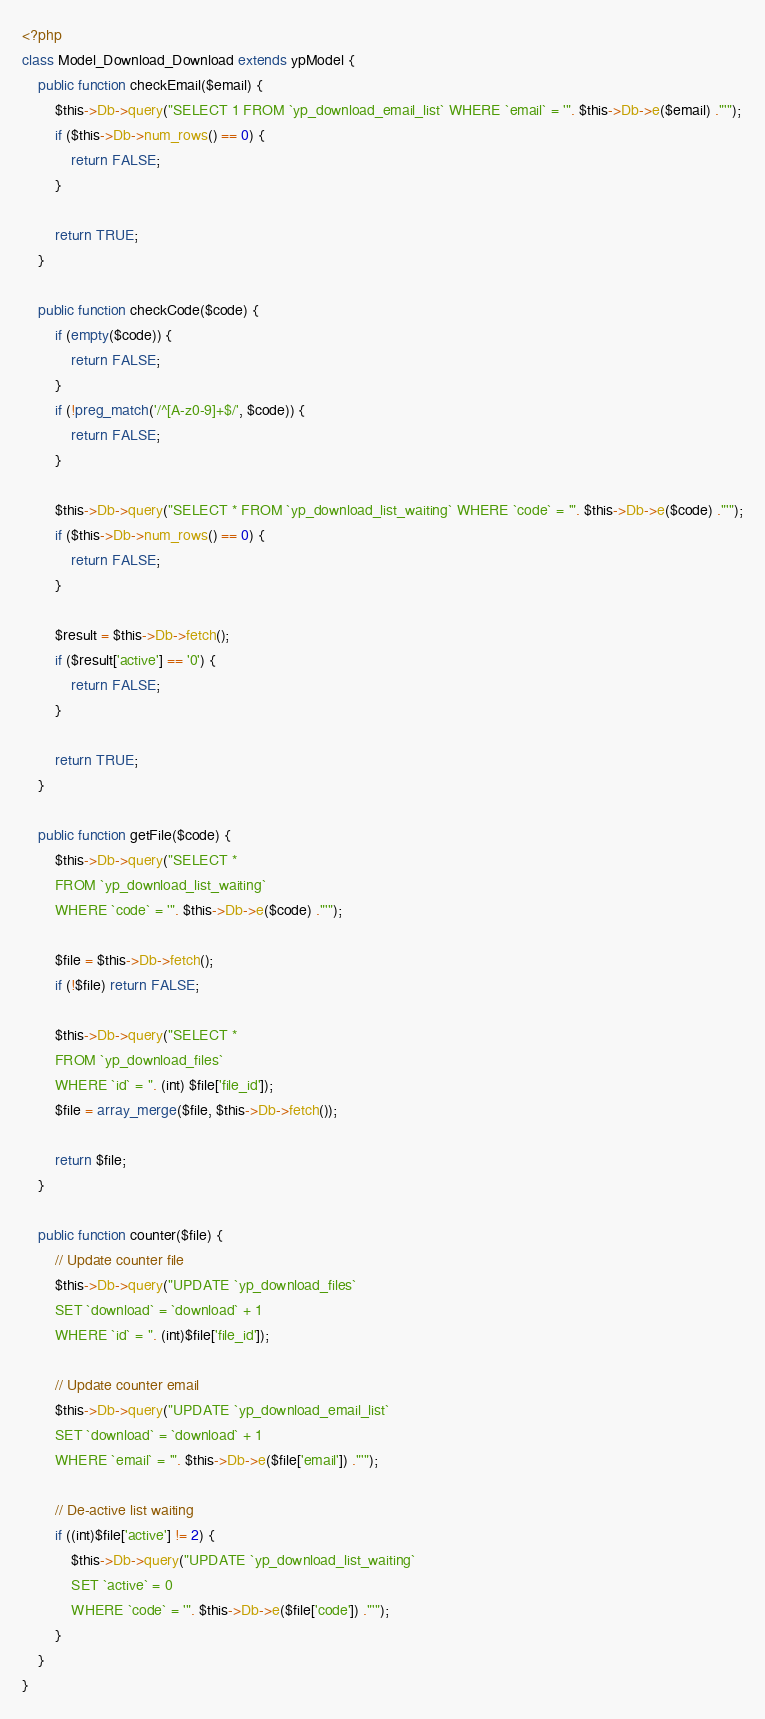<code> <loc_0><loc_0><loc_500><loc_500><_PHP_><?php class Model_Download_Download extends ypModel {	public function checkEmail($email) {		$this->Db->query("SELECT 1 FROM `yp_download_email_list` WHERE `email` = '". $this->Db->e($email) ."'");		if ($this->Db->num_rows() == 0) {			return FALSE;		}				return TRUE;	}		public function checkCode($code) {		if (empty($code)) {			return FALSE;		}		if (!preg_match('/^[A-z0-9]+$/', $code)) {			return FALSE;		}				$this->Db->query("SELECT * FROM `yp_download_list_waiting` WHERE `code` = '". $this->Db->e($code) ."'");		if ($this->Db->num_rows() == 0) {			return FALSE;		}				$result = $this->Db->fetch(); 		if ($result['active'] == '0') {			return FALSE;		}				return TRUE;	}		public function getFile($code) {		$this->Db->query("SELECT * 		FROM `yp_download_list_waiting` 		WHERE `code` = '". $this->Db->e($code) ."'");				$file = $this->Db->fetch();		if (!$file) return FALSE;				$this->Db->query("SELECT * 		FROM `yp_download_files` 		WHERE `id` = ". (int) $file['file_id']);		$file = array_merge($file, $this->Db->fetch());				return $file;	}		public function counter($file) {		// Update counter file 		$this->Db->query("UPDATE `yp_download_files` 		SET `download` = `download` + 1 		WHERE `id` = ". (int)$file['file_id']);				// Update counter email		$this->Db->query("UPDATE `yp_download_email_list`		SET `download` = `download` + 1		WHERE `email` = '". $this->Db->e($file['email']) ."'");				// De-active list waiting		if ((int)$file['active'] != 2) {			$this->Db->query("UPDATE `yp_download_list_waiting` 			SET `active` = 0			WHERE `code` = '". $this->Db->e($file['code']) ."'");		}	}}</code> 